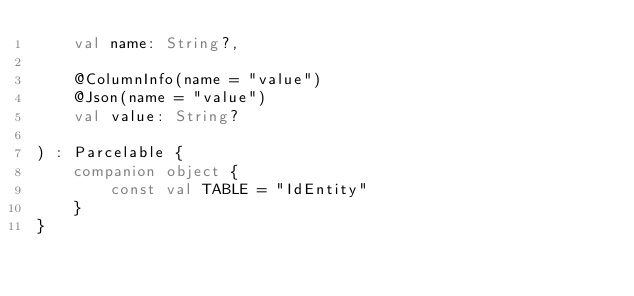<code> <loc_0><loc_0><loc_500><loc_500><_Kotlin_>    val name: String?,

    @ColumnInfo(name = "value")
    @Json(name = "value")
    val value: String?

) : Parcelable {
    companion object {
        const val TABLE = "IdEntity"
    }
}</code> 